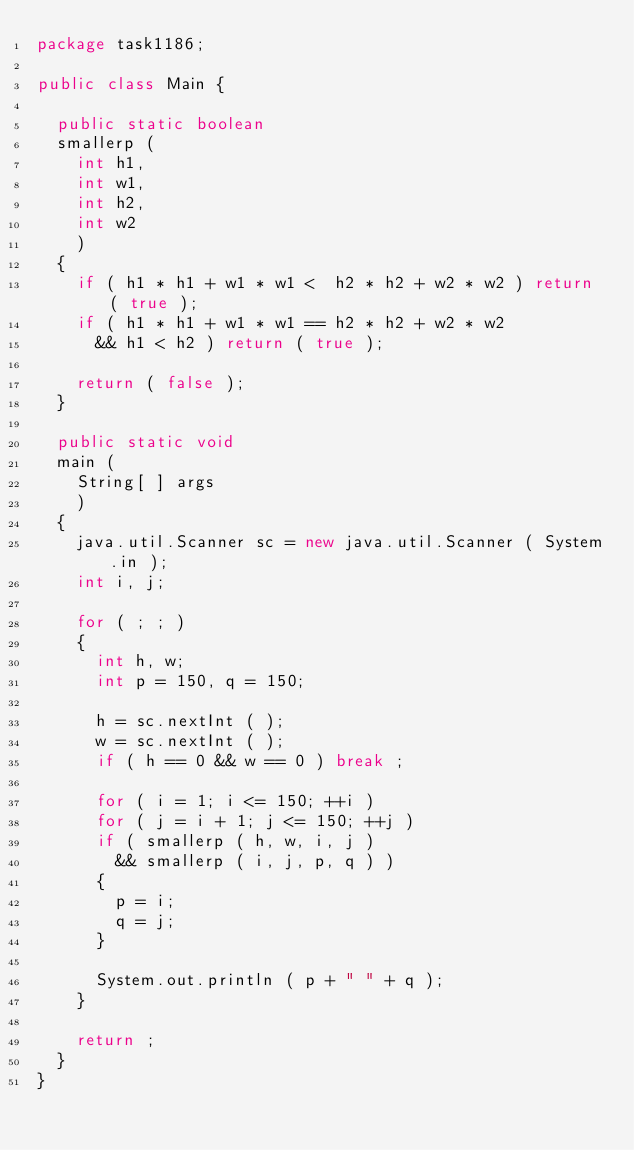Convert code to text. <code><loc_0><loc_0><loc_500><loc_500><_Java_>package task1186;

public class Main {
  
  public static boolean
  smallerp (
    int h1,
    int w1,
    int h2,
    int w2
    )
  {
    if ( h1 * h1 + w1 * w1 <  h2 * h2 + w2 * w2 ) return ( true );
    if ( h1 * h1 + w1 * w1 == h2 * h2 + w2 * w2
      && h1 < h2 ) return ( true );
    
    return ( false );
  }
  
  public static void
  main (
    String[ ] args
    )
  {
    java.util.Scanner sc = new java.util.Scanner ( System.in );
    int i, j;
    
    for ( ; ; )
    {
      int h, w;
      int p = 150, q = 150;
      
      h = sc.nextInt ( );
      w = sc.nextInt ( );
      if ( h == 0 && w == 0 ) break ;
      
      for ( i = 1; i <= 150; ++i )
      for ( j = i + 1; j <= 150; ++j )
      if ( smallerp ( h, w, i, j )
        && smallerp ( i, j, p, q ) )
      {
        p = i;
        q = j;
      }
      
      System.out.println ( p + " " + q );
    }
    
    return ;
  }
}</code> 